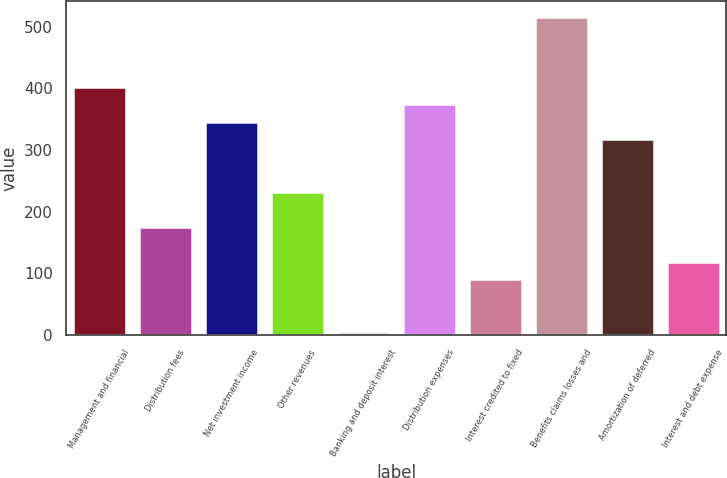<chart> <loc_0><loc_0><loc_500><loc_500><bar_chart><fcel>Management and financial<fcel>Distribution fees<fcel>Net investment income<fcel>Other revenues<fcel>Banking and deposit interest<fcel>Distribution expenses<fcel>Interest credited to fixed<fcel>Benefits claims losses and<fcel>Amortization of deferred<fcel>Interest and debt expense<nl><fcel>402.6<fcel>175.4<fcel>345.8<fcel>232.2<fcel>5<fcel>374.2<fcel>90.2<fcel>516.2<fcel>317.4<fcel>118.6<nl></chart> 